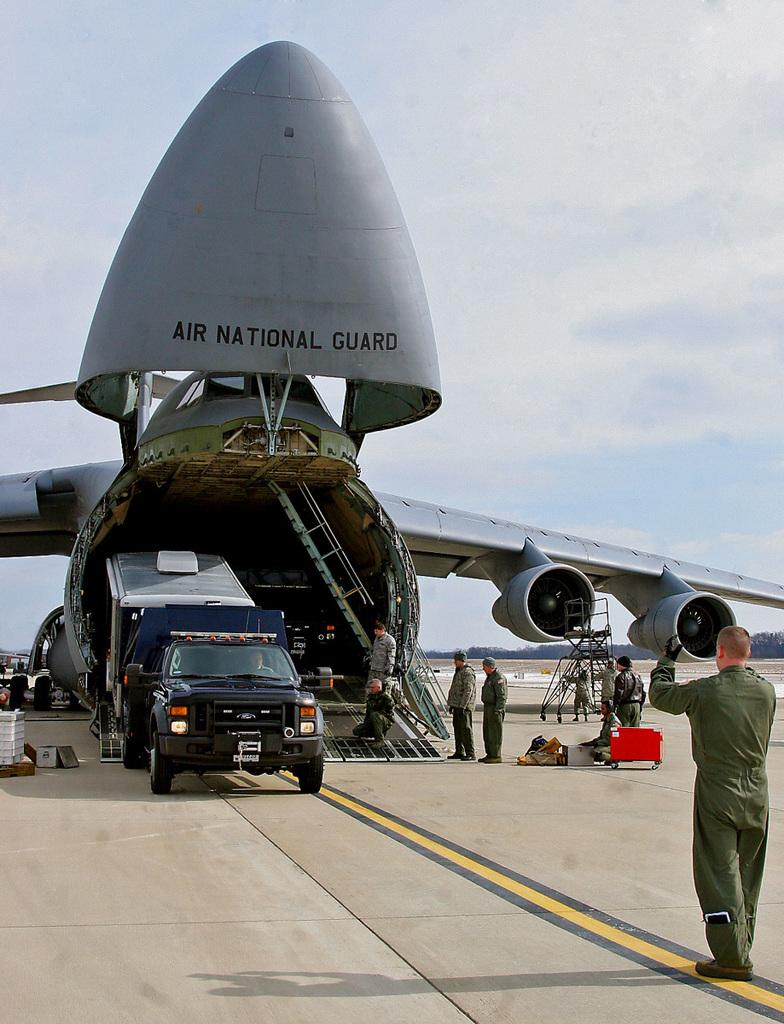<image>
Share a concise interpretation of the image provided. Air national guard's cargo plane unloads a black truck as the man in front guides it. 